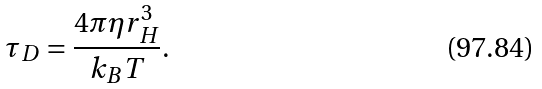<formula> <loc_0><loc_0><loc_500><loc_500>\tau _ { D } = \frac { 4 \pi \eta r _ { H } ^ { 3 } } { k _ { B } T } .</formula> 